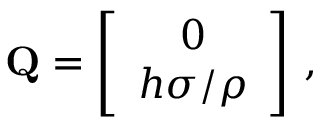<formula> <loc_0><loc_0><loc_500><loc_500>\begin{array} { r } { { Q } = \left [ \begin{array} { c } { 0 } \\ { h \sigma / \rho } \end{array} \right ] \, , } \end{array}</formula> 